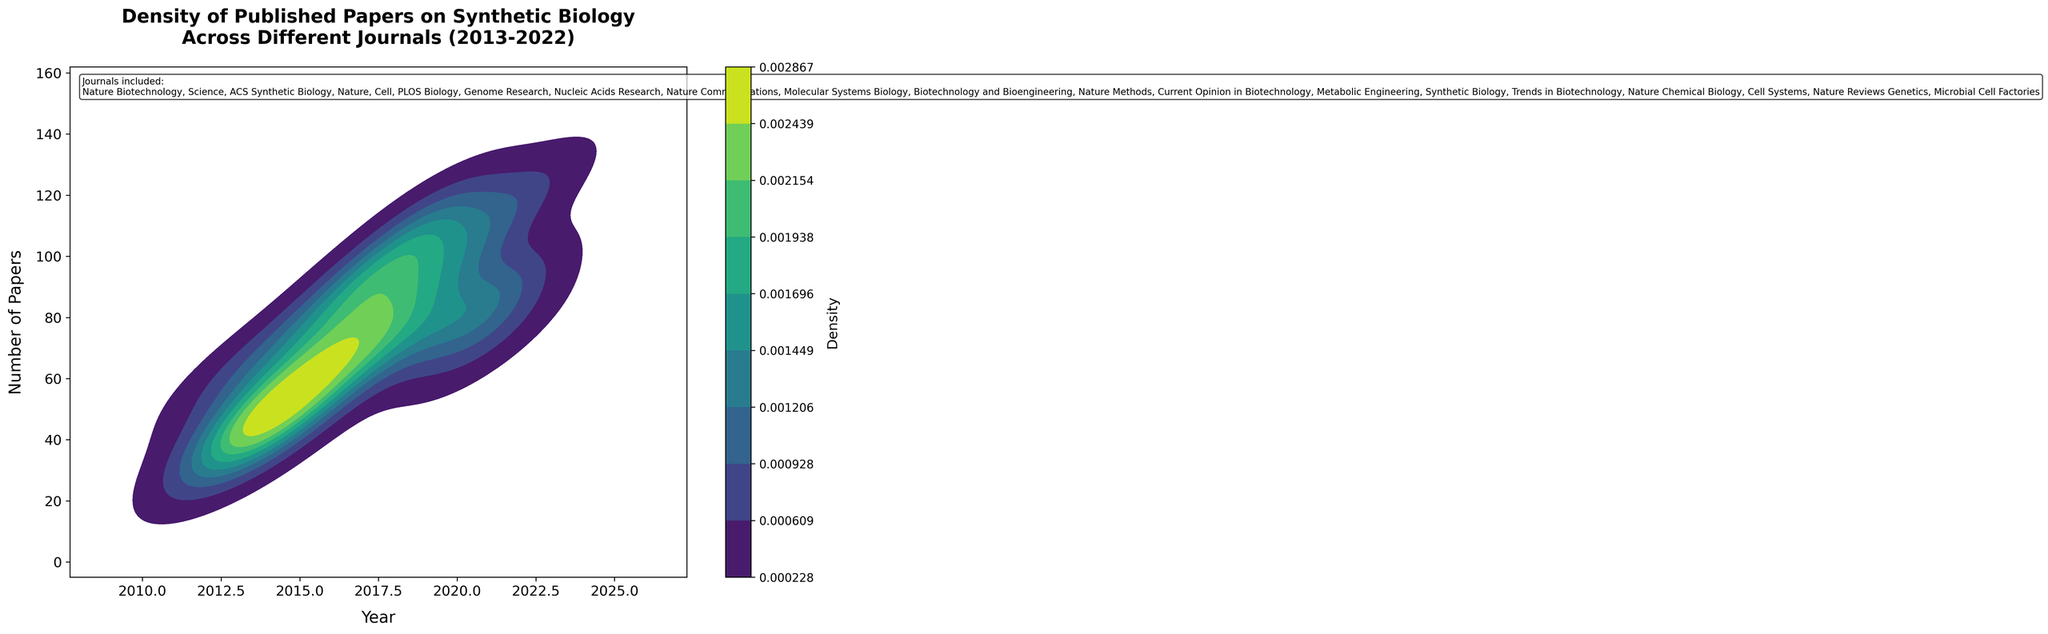What is the title of the plot? The title is written at the top of the plot, making it clear what the plot is about.
Answer: Density of Published Papers on Synthetic Biology Across Different Journals (2013-2022) What do the x and y axes represent? The labels on the x and y axes detail the aspects they represent. The x-axis is labeled "Year" and the y-axis is labeled "Number of Papers".
Answer: Year and Number of Papers Does the color intensity on this plot indicate a higher or lower density of papers? The color intensity, moving towards a darker shade, corresponds to higher density regions according to the provided colorbar.
Answer: Higher density Which year shows the highest density of published papers? By observing the color gradient and regions with the darkest shades, we can determine the highest density year. Between 2019 and 2022, we see the densest concentration.
Answer: 2019-2022 Are there more papers published around the beginning (2013-2015) or the end (2020-2022) of the decade? Comparing the density by examining both periods, it is clear that the end of the decade shows darker and more spread density regions than the beginning.
Answer: End (2020-2022) Which years exhibit the steepest increases in the number of papers? To find the steepest increases, look for areas where the density plot transitions quickly from lighter to darker shades. This happens mostly between 2015 to 2017 and also from 2018 to 2021.
Answer: 2015-2017 and 2018-2021 How many journals are included in the study? The plot includes a text box listing the journals, helping us count them.
Answer: 20 Which journal has the highest number of published papers in a single year and what is that year? According to the data grid, Metabolic Engineering in 2019 and Microbial Cell Factories in 2022 both show the highest single-year counts, with density reflecting these peaks.
Answer: Metabolic Engineering (2019) and Microbial Cell Factories (2022) How does the density of papers in 2020 compare with 2014? By comparing the intensity and area of the density regions for both years, it is clear that 2020 shows higher density than 2014.
Answer: 2020 is higher 